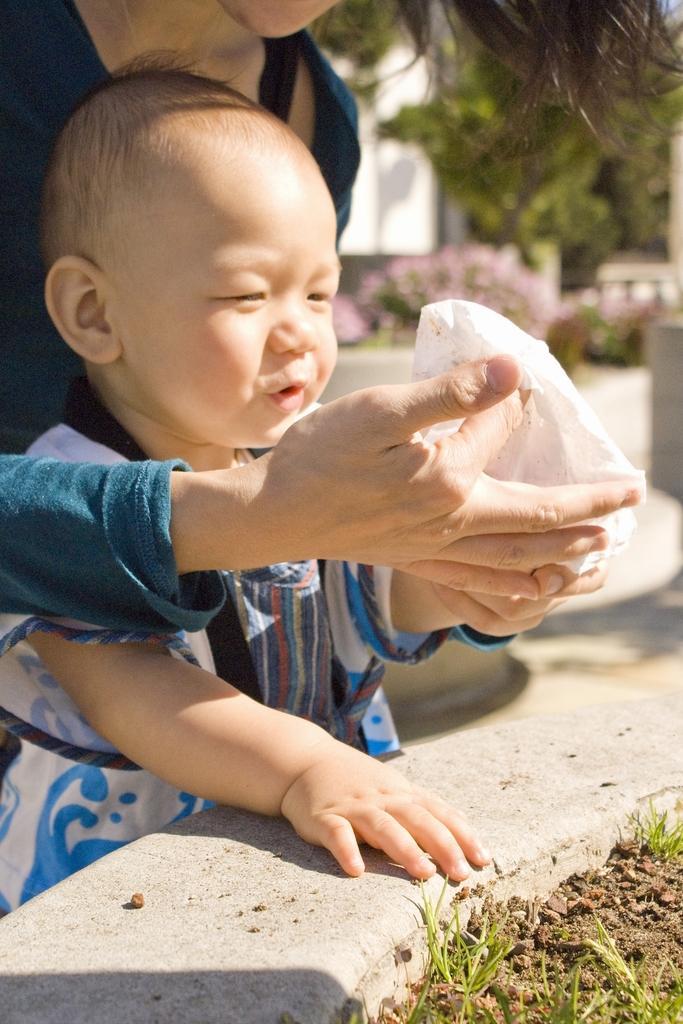In one or two sentences, can you explain what this image depicts? In this picture we can see a woman and a kid, at the right bottom we can see soil and grass, in the background there is a tree and a wall, we can see a blurry background, this woman is holding a cloth. 